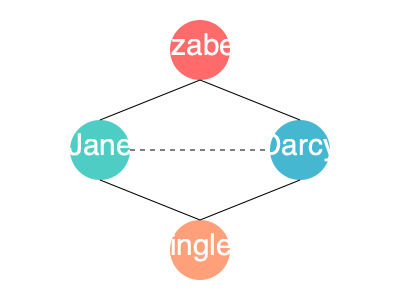Analyze the network graph representing character relationships in Jane Austen's "Pride and Prejudice." What does the dashed line between Jane and Darcy suggest about their relationship compared to the other connections in the graph? To analyze this network graph of "Pride and Prejudice" characters, let's follow these steps:

1. Identify the characters: The graph shows Elizabeth, Jane, Darcy, and Bingley as nodes.

2. Observe the connections:
   - Solid lines connect Elizabeth to Jane and Darcy
   - Solid lines connect Jane to Bingley and Elizabeth
   - Solid lines connect Darcy to Elizabeth and Bingley
   - Solid lines connect Bingley to Jane and Darcy
   - A dashed line connects Jane and Darcy

3. Interpret the connections:
   - Solid lines likely represent strong, direct relationships or interactions
   - The dashed line suggests a weaker or indirect connection

4. Analyze Jane and Darcy's relationship:
   - They are connected by a dashed line, unlike other connections
   - This implies their relationship is less direct or significant than others

5. Compare to other relationships:
   - Elizabeth has solid connections to both Jane and Darcy, indicating central, strong relationships
   - Jane and Bingley have a solid connection, suggesting a strong, direct relationship
   - Darcy and Bingley also have a solid connection, implying a close friendship

6. Conclude the meaning of the dashed line:
   - It likely represents an indirect or less significant relationship between Jane and Darcy
   - Their connection is probably mediated through other characters (Elizabeth and Bingley)
   - They may have limited direct interactions in the novel

Therefore, the dashed line suggests that Jane and Darcy have a less direct or significant relationship compared to the other connections in the graph, likely interacting primarily through their relationships with Elizabeth and Bingley.
Answer: Indirect or less significant relationship 